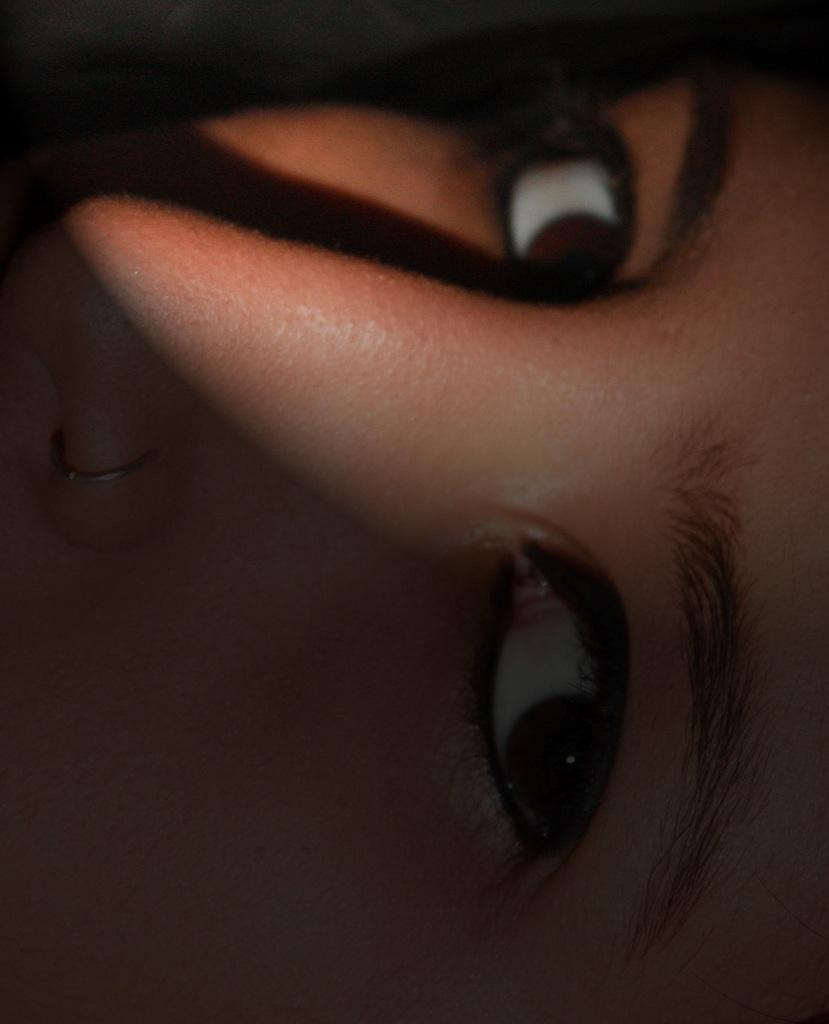What is the main subject of the image? There is a person's face in the image. What facial features can be seen on the person's face? The person's face has eyebrows, eyes, and a nose stud. What type of clover can be seen growing on the person's face in the image? There is no clover present on the person's face in the image. What type of ink is visible on the person's face in the image? There is no ink visible on the person's face in the image. What type of zephyr can be seen interacting with the person's face in the image? There is no zephyr present in the image, and therefore no such interaction can be observed. 